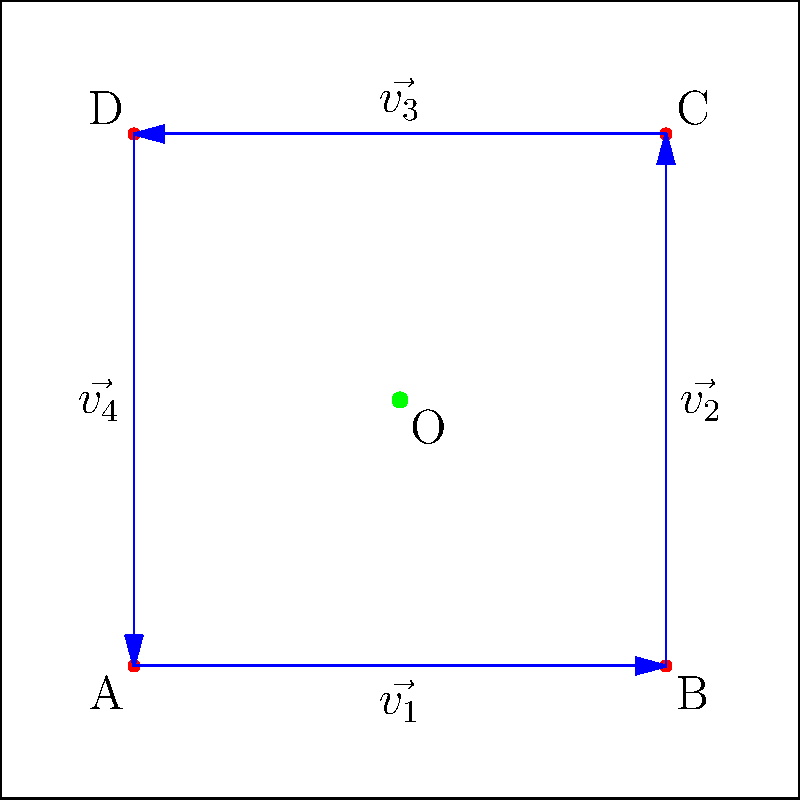For the upcoming school fundraiser, you need to determine the optimal placement of a central information booth in the rectangular courtyard. The courtyard is represented by the diagram above, where each side is 4 units long. Booths will be placed at the corners A, B, C, and D. Using vector addition, find the position vector of the optimal location (O) for the central information booth, assuming it should be equidistant from all corner booths. Let's approach this step-by-step:

1) First, we need to assign position vectors to each corner:
   A: $\vec{a} = (0,0)$
   B: $\vec{b} = (4,0)$
   C: $\vec{c} = (4,4)$
   D: $\vec{d} = (0,4)$

2) The optimal location O should be the average of these four positions. We can find this using vector addition and scalar multiplication:

   $\vec{o} = \frac{1}{4}(\vec{a} + \vec{b} + \vec{c} + \vec{d})$

3) Let's substitute the values:

   $\vec{o} = \frac{1}{4}((0,0) + (4,0) + (4,4) + (0,4))$

4) Add the vectors:

   $\vec{o} = \frac{1}{4}(8,8)$

5) Multiply by the scalar:

   $\vec{o} = (2,2)$

Therefore, the optimal location for the central information booth is at the point (2,2), which is the center of the courtyard.

This location ensures that the central booth is equidistant from all corner booths, making it easily accessible to all visitors and efficient for coordinating the fundraising activities.
Answer: $(2,2)$ 